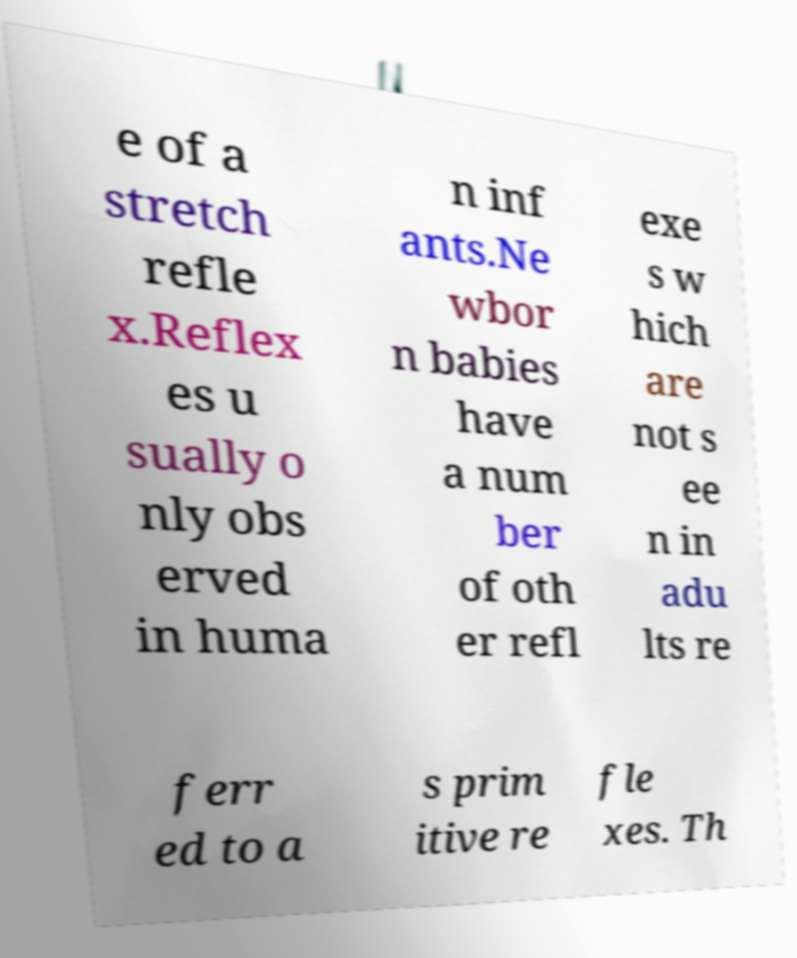Please identify and transcribe the text found in this image. e of a stretch refle x.Reflex es u sually o nly obs erved in huma n inf ants.Ne wbor n babies have a num ber of oth er refl exe s w hich are not s ee n in adu lts re ferr ed to a s prim itive re fle xes. Th 